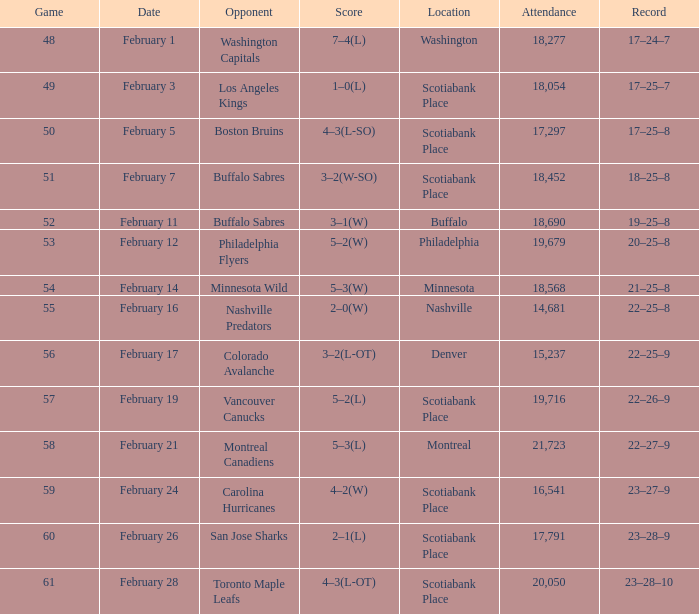What sum of game has an attendance of 18,690? 52.0. 